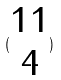Convert formula to latex. <formula><loc_0><loc_0><loc_500><loc_500>( \begin{matrix} 1 1 \\ 4 \end{matrix} )</formula> 